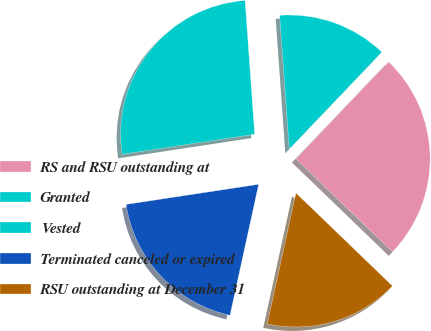Convert chart. <chart><loc_0><loc_0><loc_500><loc_500><pie_chart><fcel>RS and RSU outstanding at<fcel>Granted<fcel>Vested<fcel>Terminated canceled or expired<fcel>RSU outstanding at December 31<nl><fcel>25.07%<fcel>13.27%<fcel>26.25%<fcel>19.17%<fcel>16.22%<nl></chart> 